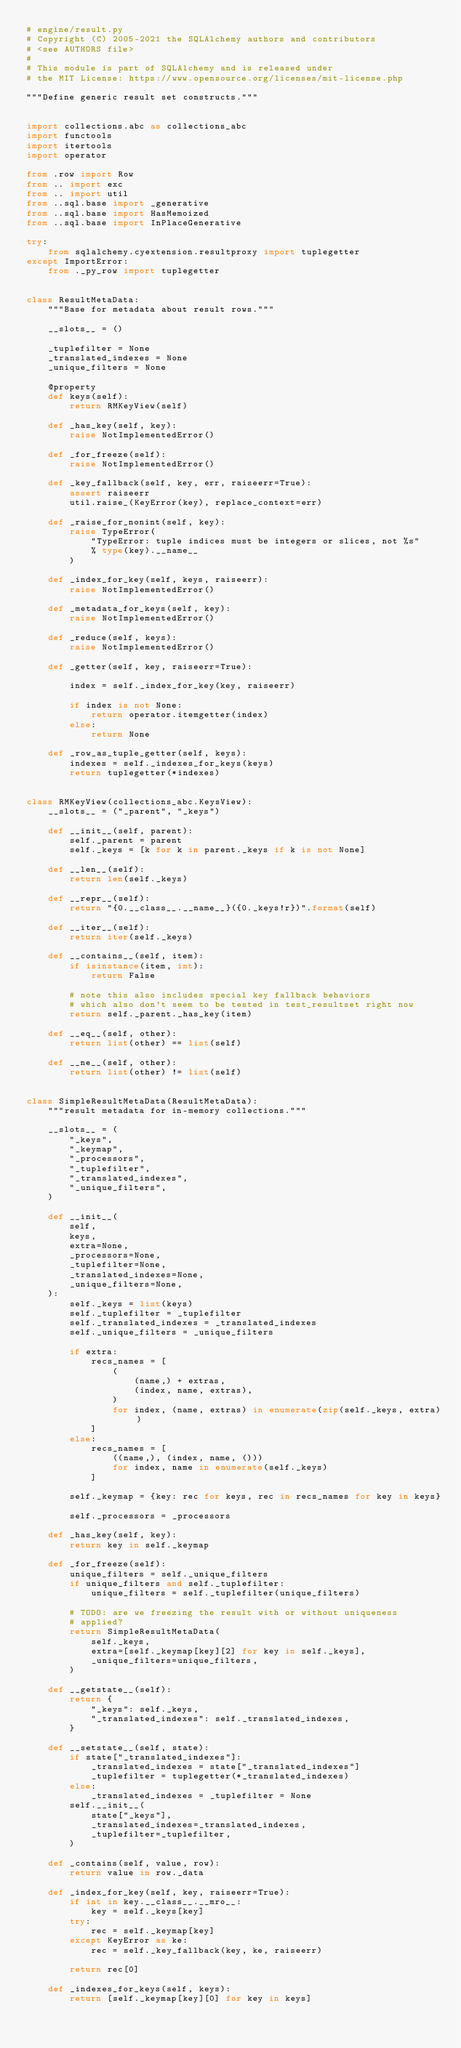<code> <loc_0><loc_0><loc_500><loc_500><_Python_># engine/result.py
# Copyright (C) 2005-2021 the SQLAlchemy authors and contributors
# <see AUTHORS file>
#
# This module is part of SQLAlchemy and is released under
# the MIT License: https://www.opensource.org/licenses/mit-license.php

"""Define generic result set constructs."""


import collections.abc as collections_abc
import functools
import itertools
import operator

from .row import Row
from .. import exc
from .. import util
from ..sql.base import _generative
from ..sql.base import HasMemoized
from ..sql.base import InPlaceGenerative

try:
    from sqlalchemy.cyextension.resultproxy import tuplegetter
except ImportError:
    from ._py_row import tuplegetter


class ResultMetaData:
    """Base for metadata about result rows."""

    __slots__ = ()

    _tuplefilter = None
    _translated_indexes = None
    _unique_filters = None

    @property
    def keys(self):
        return RMKeyView(self)

    def _has_key(self, key):
        raise NotImplementedError()

    def _for_freeze(self):
        raise NotImplementedError()

    def _key_fallback(self, key, err, raiseerr=True):
        assert raiseerr
        util.raise_(KeyError(key), replace_context=err)

    def _raise_for_nonint(self, key):
        raise TypeError(
            "TypeError: tuple indices must be integers or slices, not %s"
            % type(key).__name__
        )

    def _index_for_key(self, keys, raiseerr):
        raise NotImplementedError()

    def _metadata_for_keys(self, key):
        raise NotImplementedError()

    def _reduce(self, keys):
        raise NotImplementedError()

    def _getter(self, key, raiseerr=True):

        index = self._index_for_key(key, raiseerr)

        if index is not None:
            return operator.itemgetter(index)
        else:
            return None

    def _row_as_tuple_getter(self, keys):
        indexes = self._indexes_for_keys(keys)
        return tuplegetter(*indexes)


class RMKeyView(collections_abc.KeysView):
    __slots__ = ("_parent", "_keys")

    def __init__(self, parent):
        self._parent = parent
        self._keys = [k for k in parent._keys if k is not None]

    def __len__(self):
        return len(self._keys)

    def __repr__(self):
        return "{0.__class__.__name__}({0._keys!r})".format(self)

    def __iter__(self):
        return iter(self._keys)

    def __contains__(self, item):
        if isinstance(item, int):
            return False

        # note this also includes special key fallback behaviors
        # which also don't seem to be tested in test_resultset right now
        return self._parent._has_key(item)

    def __eq__(self, other):
        return list(other) == list(self)

    def __ne__(self, other):
        return list(other) != list(self)


class SimpleResultMetaData(ResultMetaData):
    """result metadata for in-memory collections."""

    __slots__ = (
        "_keys",
        "_keymap",
        "_processors",
        "_tuplefilter",
        "_translated_indexes",
        "_unique_filters",
    )

    def __init__(
        self,
        keys,
        extra=None,
        _processors=None,
        _tuplefilter=None,
        _translated_indexes=None,
        _unique_filters=None,
    ):
        self._keys = list(keys)
        self._tuplefilter = _tuplefilter
        self._translated_indexes = _translated_indexes
        self._unique_filters = _unique_filters

        if extra:
            recs_names = [
                (
                    (name,) + extras,
                    (index, name, extras),
                )
                for index, (name, extras) in enumerate(zip(self._keys, extra))
            ]
        else:
            recs_names = [
                ((name,), (index, name, ()))
                for index, name in enumerate(self._keys)
            ]

        self._keymap = {key: rec for keys, rec in recs_names for key in keys}

        self._processors = _processors

    def _has_key(self, key):
        return key in self._keymap

    def _for_freeze(self):
        unique_filters = self._unique_filters
        if unique_filters and self._tuplefilter:
            unique_filters = self._tuplefilter(unique_filters)

        # TODO: are we freezing the result with or without uniqueness
        # applied?
        return SimpleResultMetaData(
            self._keys,
            extra=[self._keymap[key][2] for key in self._keys],
            _unique_filters=unique_filters,
        )

    def __getstate__(self):
        return {
            "_keys": self._keys,
            "_translated_indexes": self._translated_indexes,
        }

    def __setstate__(self, state):
        if state["_translated_indexes"]:
            _translated_indexes = state["_translated_indexes"]
            _tuplefilter = tuplegetter(*_translated_indexes)
        else:
            _translated_indexes = _tuplefilter = None
        self.__init__(
            state["_keys"],
            _translated_indexes=_translated_indexes,
            _tuplefilter=_tuplefilter,
        )

    def _contains(self, value, row):
        return value in row._data

    def _index_for_key(self, key, raiseerr=True):
        if int in key.__class__.__mro__:
            key = self._keys[key]
        try:
            rec = self._keymap[key]
        except KeyError as ke:
            rec = self._key_fallback(key, ke, raiseerr)

        return rec[0]

    def _indexes_for_keys(self, keys):
        return [self._keymap[key][0] for key in keys]
</code> 